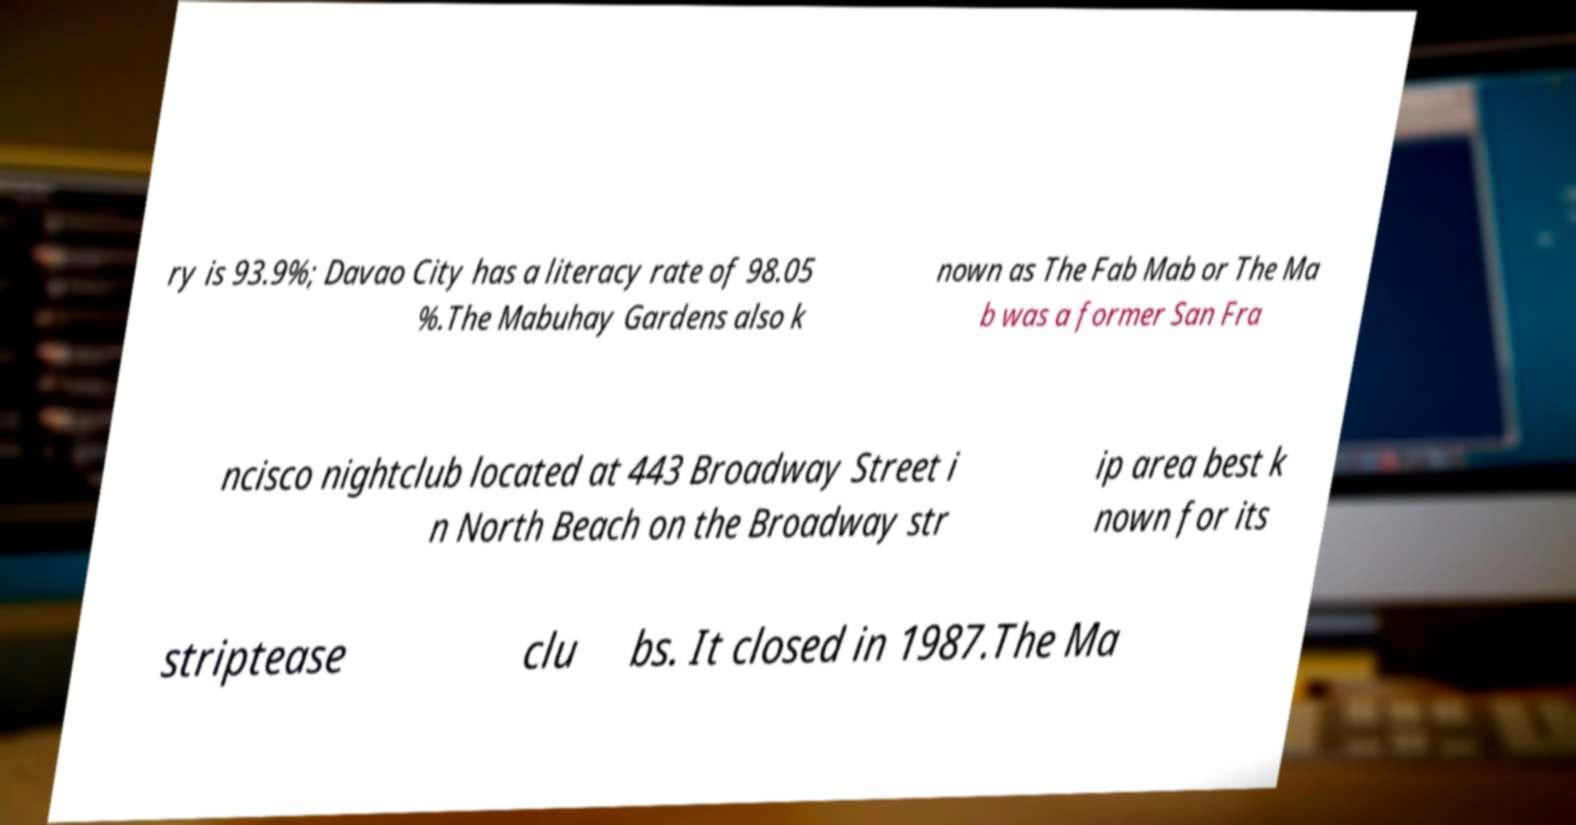Can you accurately transcribe the text from the provided image for me? ry is 93.9%; Davao City has a literacy rate of 98.05 %.The Mabuhay Gardens also k nown as The Fab Mab or The Ma b was a former San Fra ncisco nightclub located at 443 Broadway Street i n North Beach on the Broadway str ip area best k nown for its striptease clu bs. It closed in 1987.The Ma 